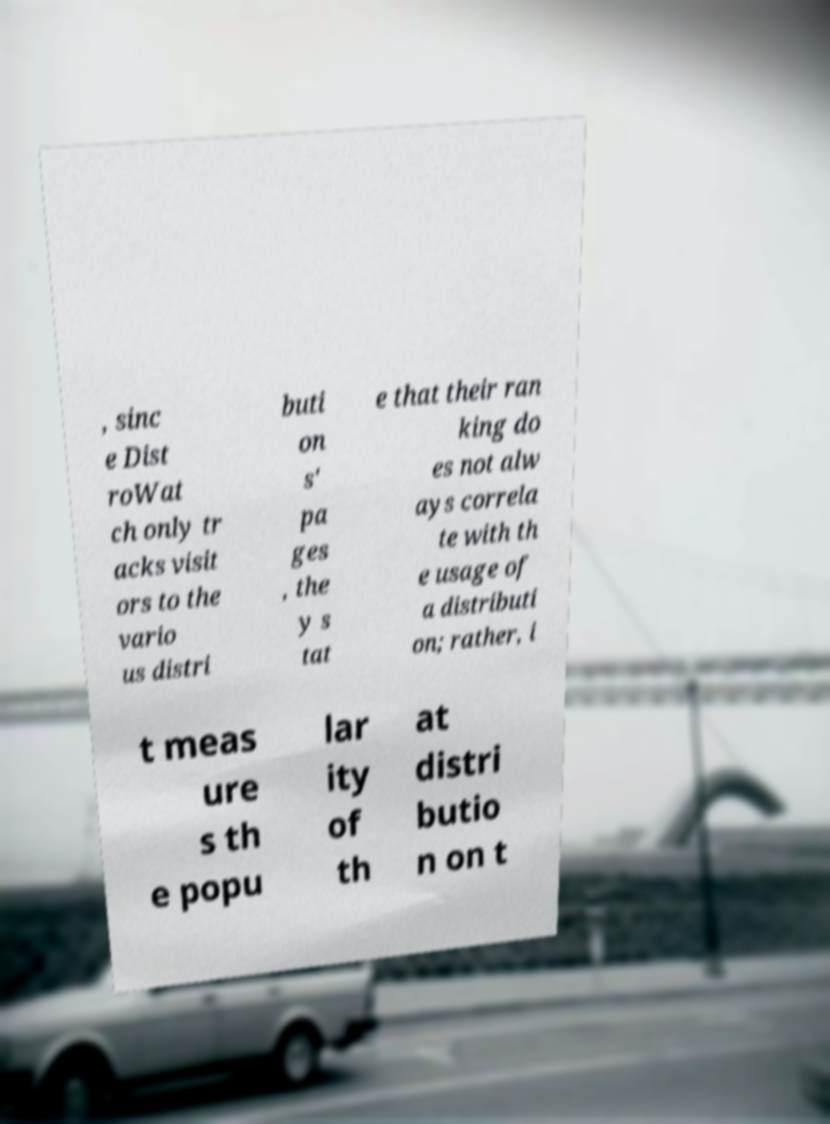Could you extract and type out the text from this image? , sinc e Dist roWat ch only tr acks visit ors to the vario us distri buti on s' pa ges , the y s tat e that their ran king do es not alw ays correla te with th e usage of a distributi on; rather, i t meas ure s th e popu lar ity of th at distri butio n on t 